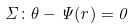Convert formula to latex. <formula><loc_0><loc_0><loc_500><loc_500>\Sigma \colon \theta - \Psi ( r ) = 0</formula> 